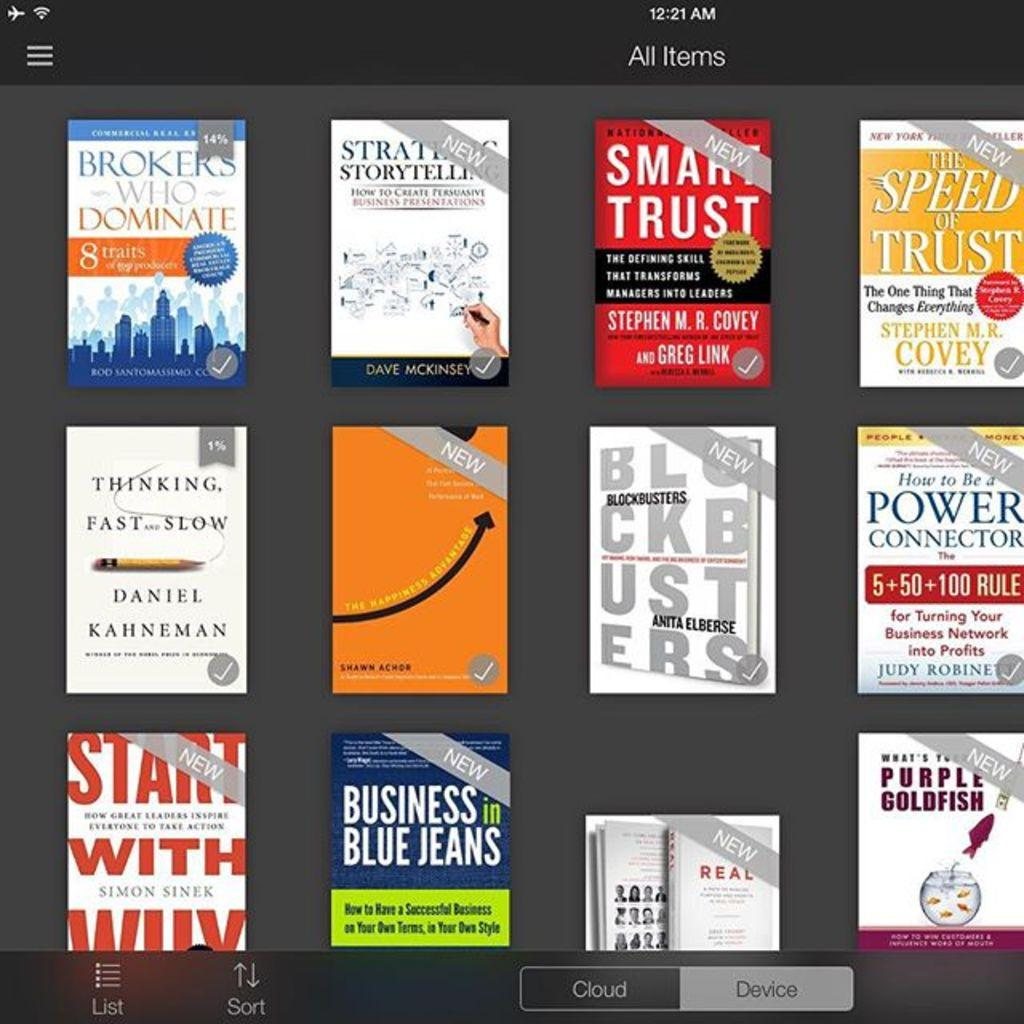What is the main subject of the image? The main subject of the image is a screen. What is displayed on the screen? There are books displayed on the screen. How are the books shown on the screen? The books are shown in a front view. Are there any additional features on the screen? Yes, there are options at the bottom of the screen. Can you see a picture of a sail on the screen? There is no picture of a sail present on the screen; it displays books. Is there any quartz visible on the screen? There is no quartz visible on the screen; it displays books and options. 